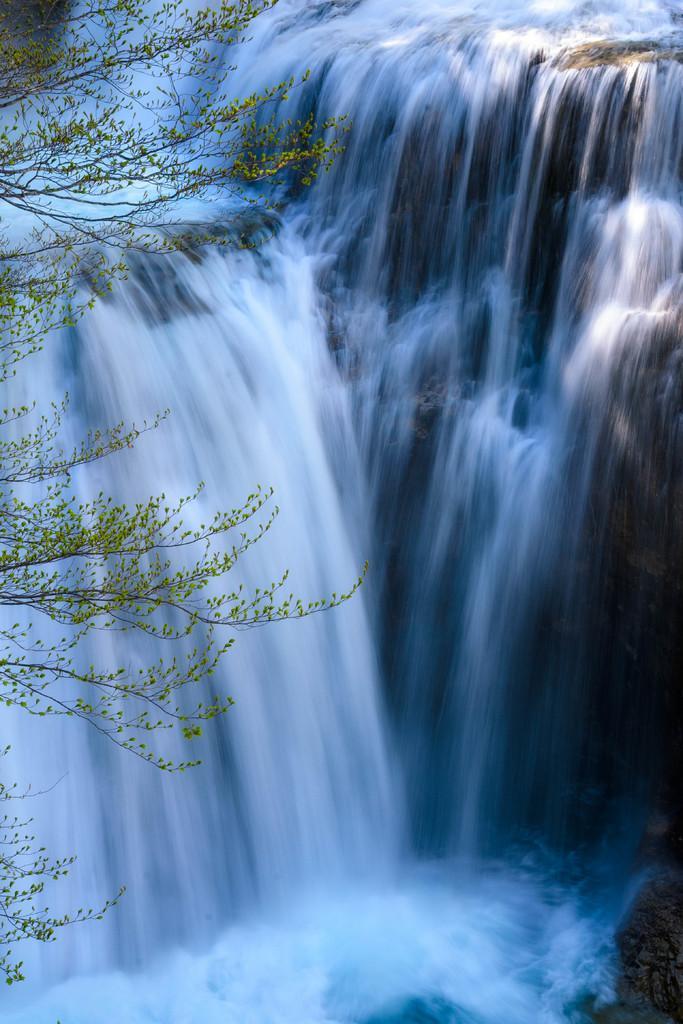Could you give a brief overview of what you see in this image? In this picture we can see waterfalls and trees. 